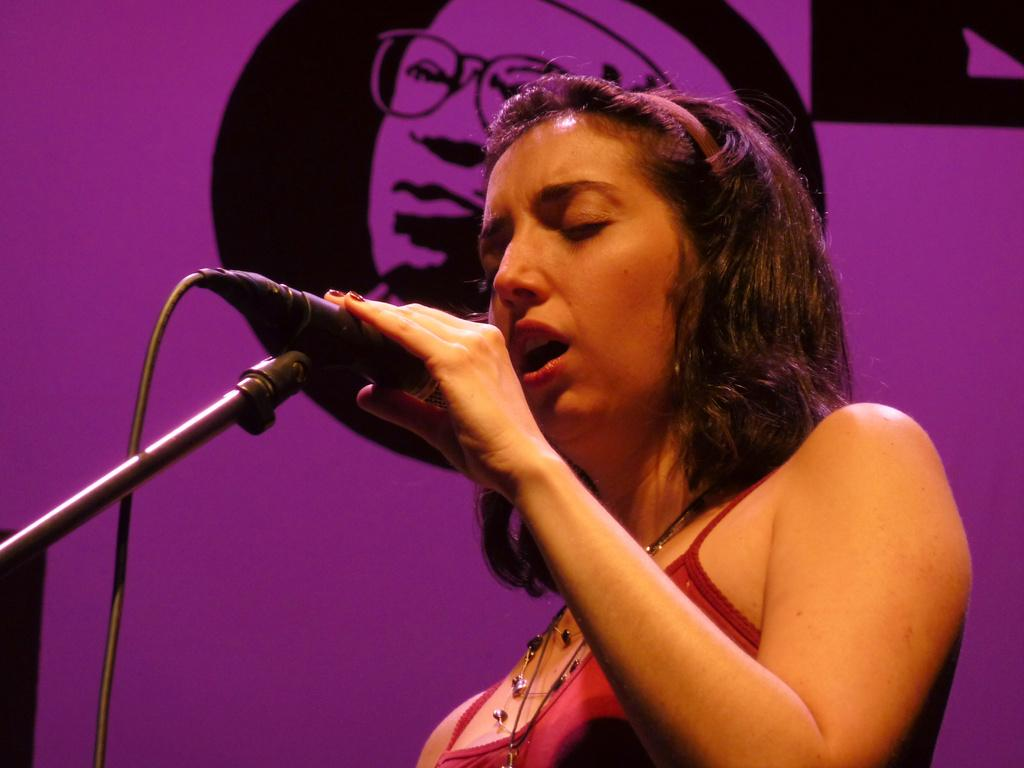Who is the main subject in the image? There is a woman in the image. What is the woman wearing? The woman is wearing a red dress. What is the woman doing in the image? The woman is standing and holding a microphone in her hand. What can be seen in the background of the image? There is a pink banner in the background of the image, and it has a person printed on it. What type of frame is around the woman in the image? There is no frame around the woman in the image; she is standing in an open space. What feeling does the woman express in the image? The image does not convey a specific emotion or feeling; it only shows the woman standing and holding a microphone. 